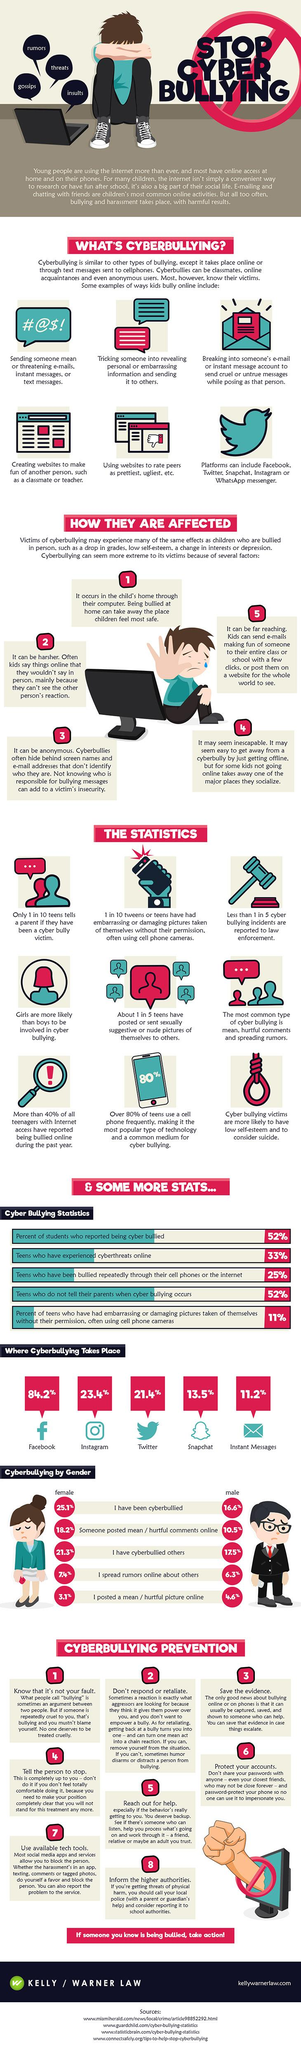Give some essential details in this illustration. According to the infographic, you should follow 8 key points to prevent cyberbullying. It is reported that five points are given under how people are affected. Cyberbullying most frequently occurs on Instagram, which is the second most frequented place for this type of behavior. The color of the icon for instant messages is blue. In most forms, female gender faces higher percentages of cyberbullying compared to male gender. 